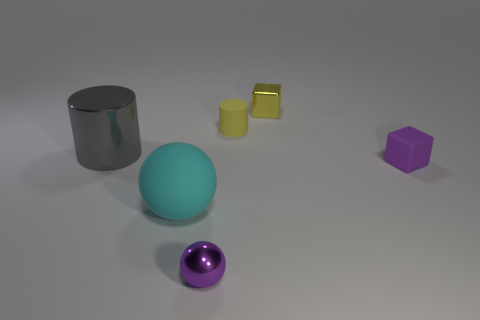Add 2 large metal cylinders. How many objects exist? 8 Subtract all cubes. How many objects are left? 4 Add 3 small brown shiny balls. How many small brown shiny balls exist? 3 Subtract 0 gray cubes. How many objects are left? 6 Subtract all brown shiny spheres. Subtract all metal spheres. How many objects are left? 5 Add 5 purple metallic spheres. How many purple metallic spheres are left? 6 